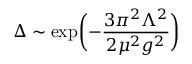<formula> <loc_0><loc_0><loc_500><loc_500>\Delta \sim \exp \left ( - { \frac { 3 \pi ^ { 2 } \Lambda ^ { 2 } } { 2 \mu ^ { 2 } g ^ { 2 } } } \right )</formula> 